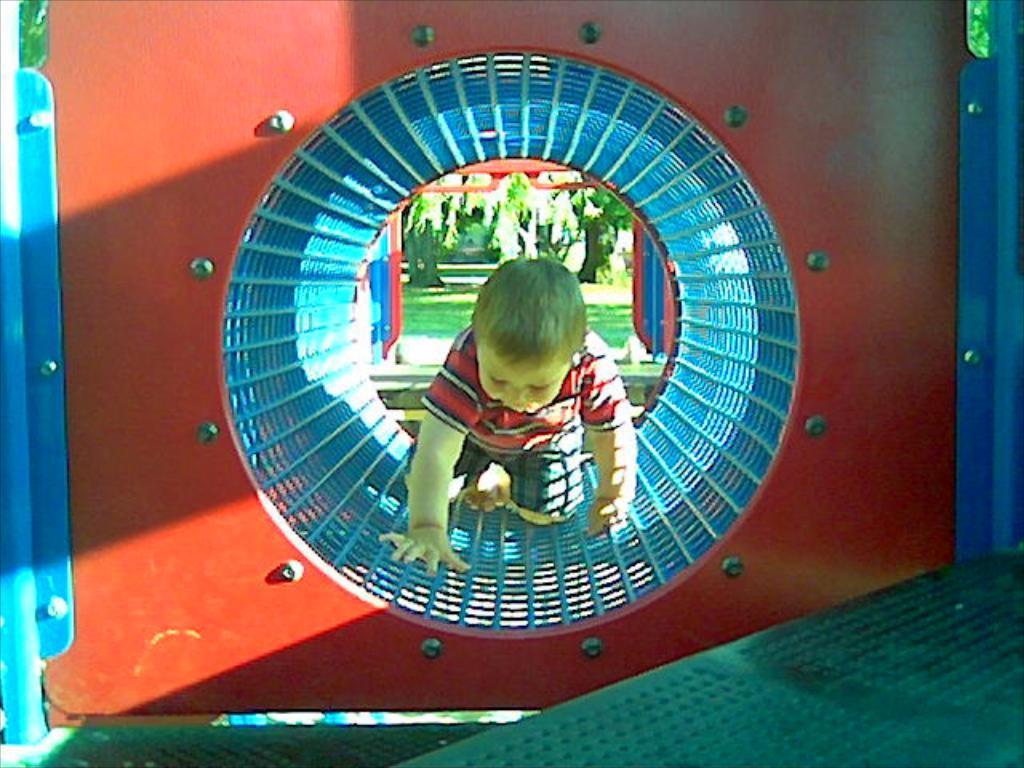Please provide a concise description of this image. In this image we can see a red color object and there is a boy in the center of the object. In the background we can see some trees. 